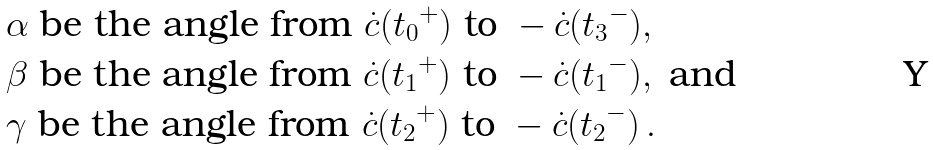<formula> <loc_0><loc_0><loc_500><loc_500>& \alpha \text { be the angle from } \dot { c } ( { t _ { 0 } } ^ { + } ) \text { to } - \dot { c } ( { t _ { 3 } } ^ { - } ) , \\ & \beta \text { be the angle from } \dot { c } ( { t _ { 1 } } ^ { + } ) \text { to } - \dot { c } ( { t _ { 1 } } ^ { - } ) , \text { and } \\ & \gamma \text { be the angle from } \dot { c } ( { t _ { 2 } } ^ { + } ) \text { to } - \dot { c } ( { t _ { 2 } } ^ { - } ) \, .</formula> 